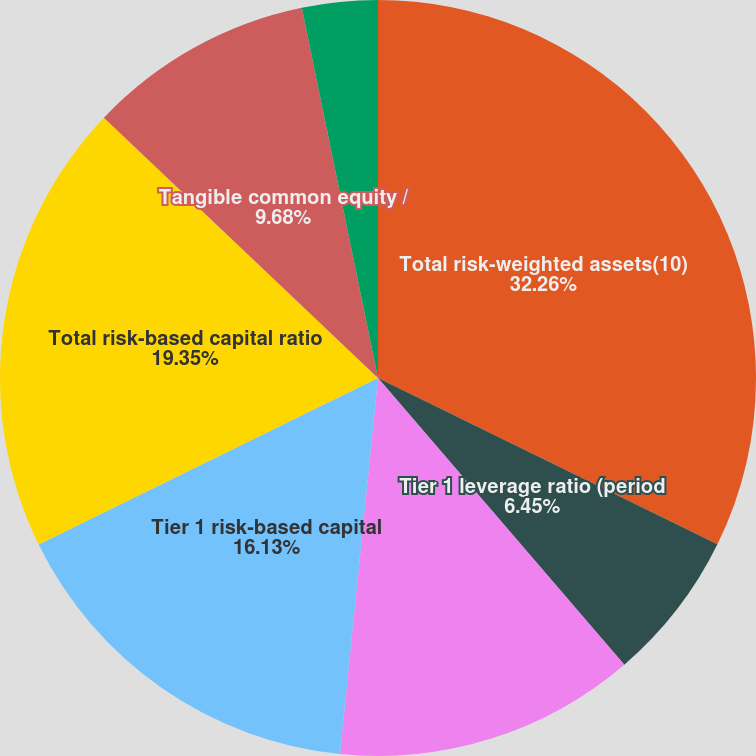<chart> <loc_0><loc_0><loc_500><loc_500><pie_chart><fcel>Total risk-weighted assets(10)<fcel>Tier 1 leverage ratio (period<fcel>Common equity tier 1<fcel>Tier 1 risk-based capital<fcel>Total risk-based capital ratio<fcel>Tangible common equity /<fcel>Tangible equity / tangible<nl><fcel>32.25%<fcel>6.45%<fcel>12.9%<fcel>16.13%<fcel>19.35%<fcel>9.68%<fcel>3.23%<nl></chart> 